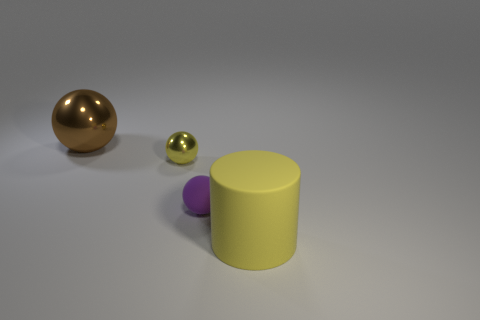Add 2 small metallic things. How many objects exist? 6 Subtract all cylinders. How many objects are left? 3 Add 2 tiny brown cubes. How many tiny brown cubes exist? 2 Subtract 0 cyan spheres. How many objects are left? 4 Subtract all yellow spheres. Subtract all large blue matte balls. How many objects are left? 3 Add 4 tiny yellow metallic things. How many tiny yellow metallic things are left? 5 